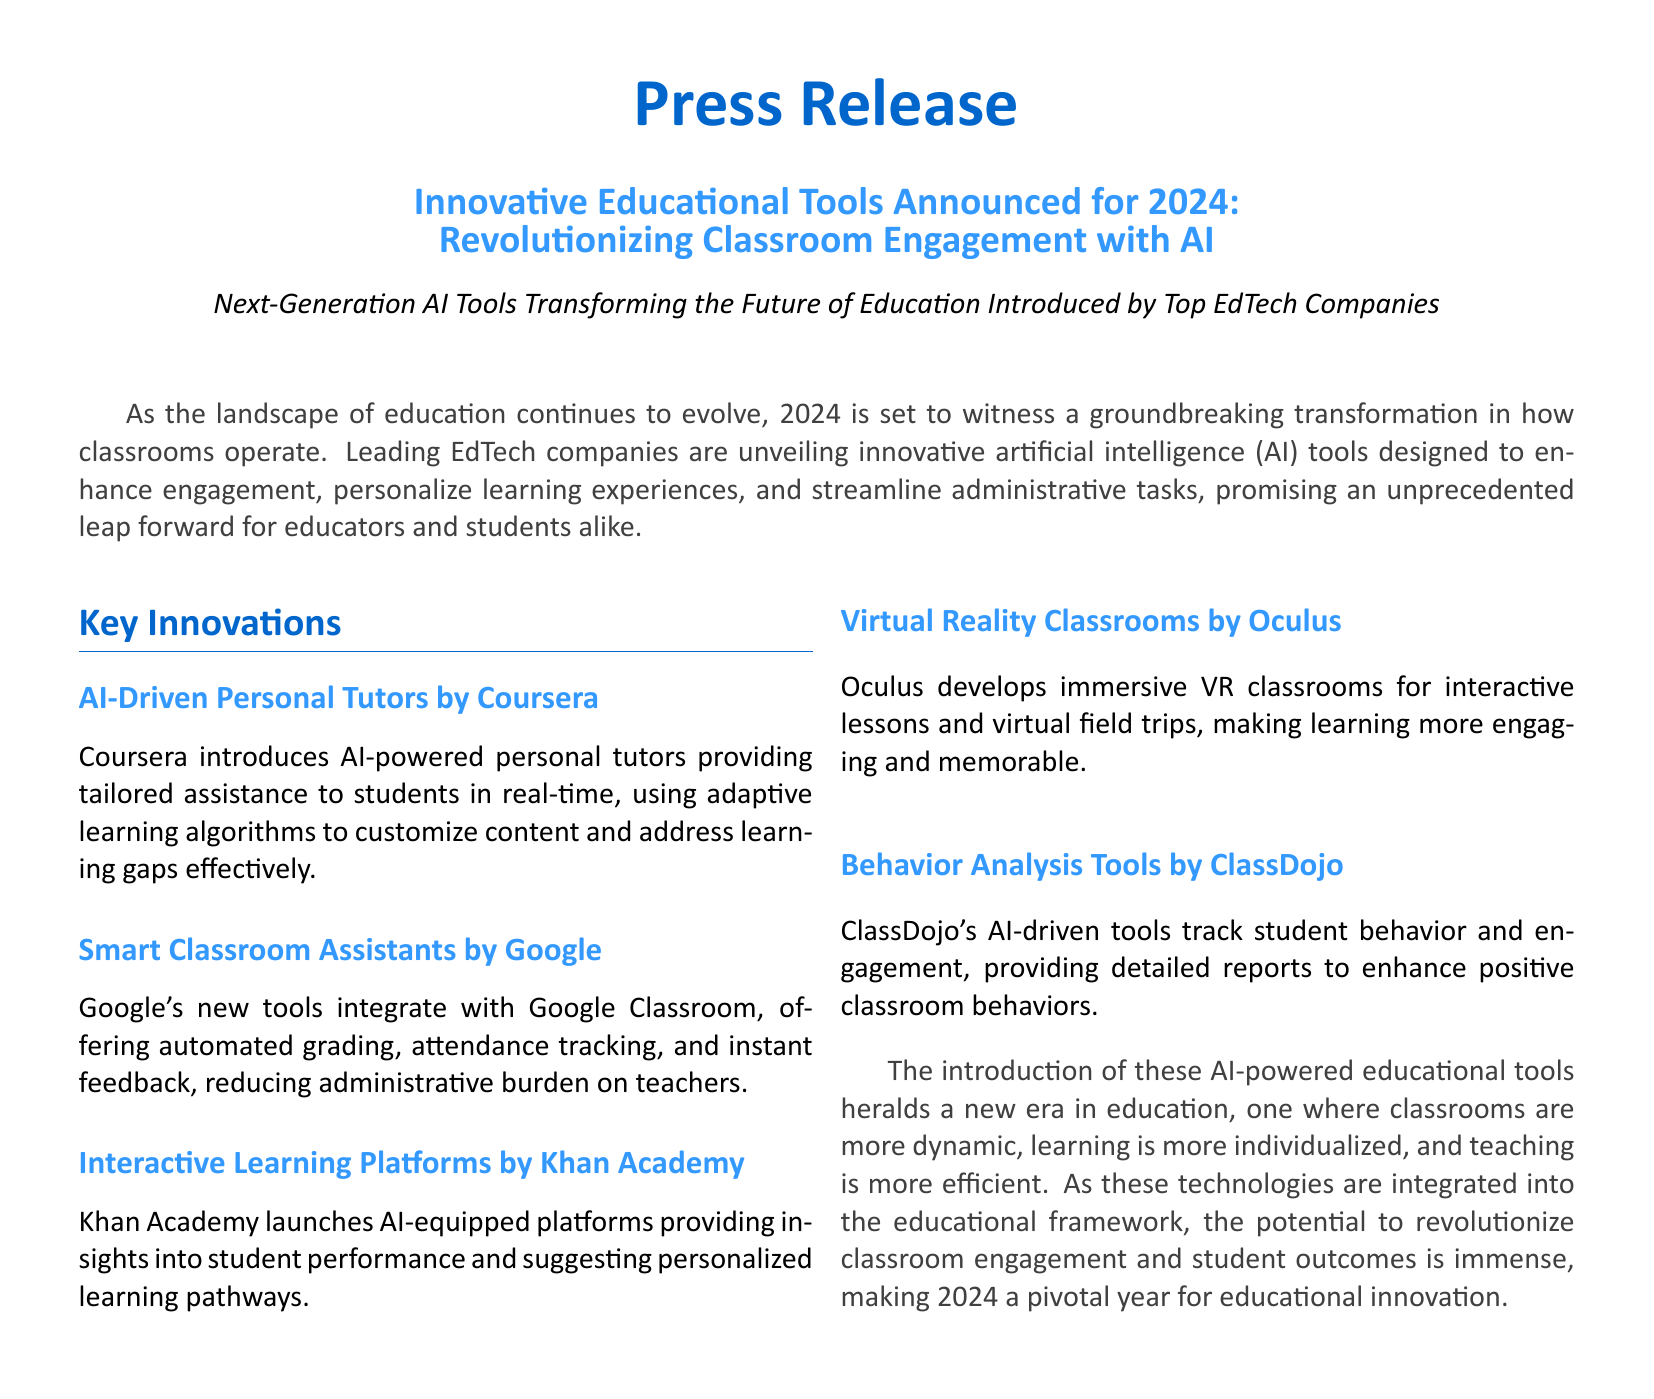What is the year for the announced innovations? The document specifies that the innovations are announced for the year 2024.
Answer: 2024 Who introduced AI-driven personal tutors? The document states that Coursera introduces AI-driven personal tutors.
Answer: Coursera What technology does Google's new tools integrate with? According to the document, Google's new tools integrate with Google Classroom.
Answer: Google Classroom Which company developed immersive VR classrooms? The document mentions that Oculus develops immersive VR classrooms.
Answer: Oculus What type of tools do ClassDojo provide? The document indicates that ClassDojo provides behavior analysis tools.
Answer: behavior analysis tools How does the new AI technology impact classroom engagement? The document explains that these AI-powered educational tools enhance engagement and personalize learning experiences.
Answer: enhance engagement and personalize learning experiences What does Khan Academy's platform offer insights into? The document notes that Khan Academy's platform provides insights into student performance.
Answer: student performance What major benefit do the Smart Classroom Assistants provide? The document highlights that they offer automated grading, attendance tracking, and instant feedback.
Answer: automated grading, attendance tracking, and instant feedback 